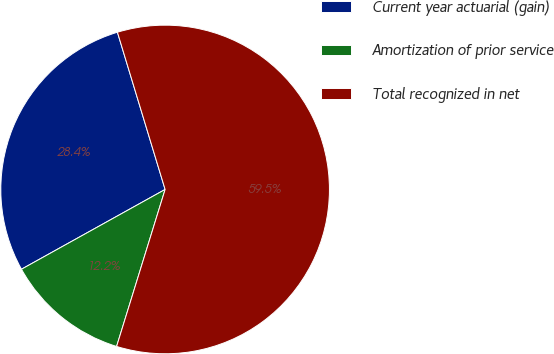Convert chart to OTSL. <chart><loc_0><loc_0><loc_500><loc_500><pie_chart><fcel>Current year actuarial (gain)<fcel>Amortization of prior service<fcel>Total recognized in net<nl><fcel>28.38%<fcel>12.16%<fcel>59.46%<nl></chart> 